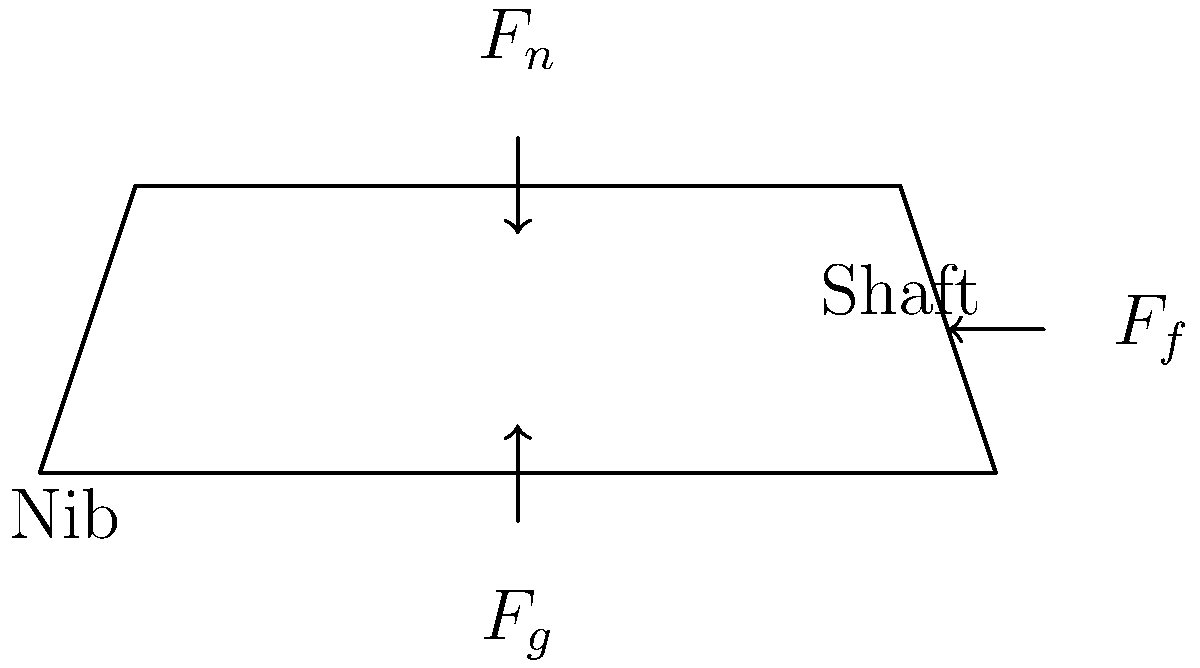Consider the biomechanical forces acting on a quill pen during writing in the 18th century. How would the normal force ($F_n$) exerted by the writer's hand differ when using a quill pen compared to modern ballpoint pens, and how might this have influenced the development of writing styles and literary works of that era? To understand the biomechanical forces acting on a quill pen during writing in the 18th century, let's break down the analysis step-by-step:

1. Force components:
   - $F_g$: Gravitational force acting downward on the pen
   - $F_n$: Normal force exerted by the writer's hand
   - $F_f$: Frictional force between the pen nib and the writing surface

2. Quill pen characteristics:
   - Made from bird feathers, typically goose or swan
   - Lightweight compared to modern pens
   - Flexible nib that requires careful pressure control

3. Writing process with a quill pen:
   - The writer needs to apply more precise control over the normal force ($F_n$)
   - Too much pressure can cause the nib to splay or damage the paper
   - Too little pressure results in inconsistent ink flow

4. Comparison with modern ballpoint pens:
   - Ballpoint pens require less precise pressure control
   - They have a more consistent ink flow due to the ball mechanism
   - The normal force ($F_n$) can be applied more uniformly

5. Impact on writing styles:
   - Quill pens encouraged a lighter touch and more controlled hand movements
   - This led to the development of elegant, flowing scripts like Copperplate
   - Writers had to pause more frequently to re-ink the pen, influencing pacing and thought processes

6. Influence on literary works:
   - The physical act of writing with a quill pen was more time-consuming
   - This may have encouraged more thoughtful composition and revision
   - The limited ink capacity might have influenced the length of sentences and paragraphs

7. Historical context:
   - The 18th century saw a rise in literacy and written communication
   - The physicality of quill pen writing may have contributed to the formal and elaborate writing styles of the era

In conclusion, the normal force ($F_n$) required for writing with a quill pen was generally lighter and more variable than with modern ballpoint pens. This necessity for precise control influenced the development of writing styles, encouraging elegant scripts and potentially affecting the composition and structure of literary works in the 18th century.
Answer: Lighter, more variable normal force; influenced elegant scripts and thoughtful composition 